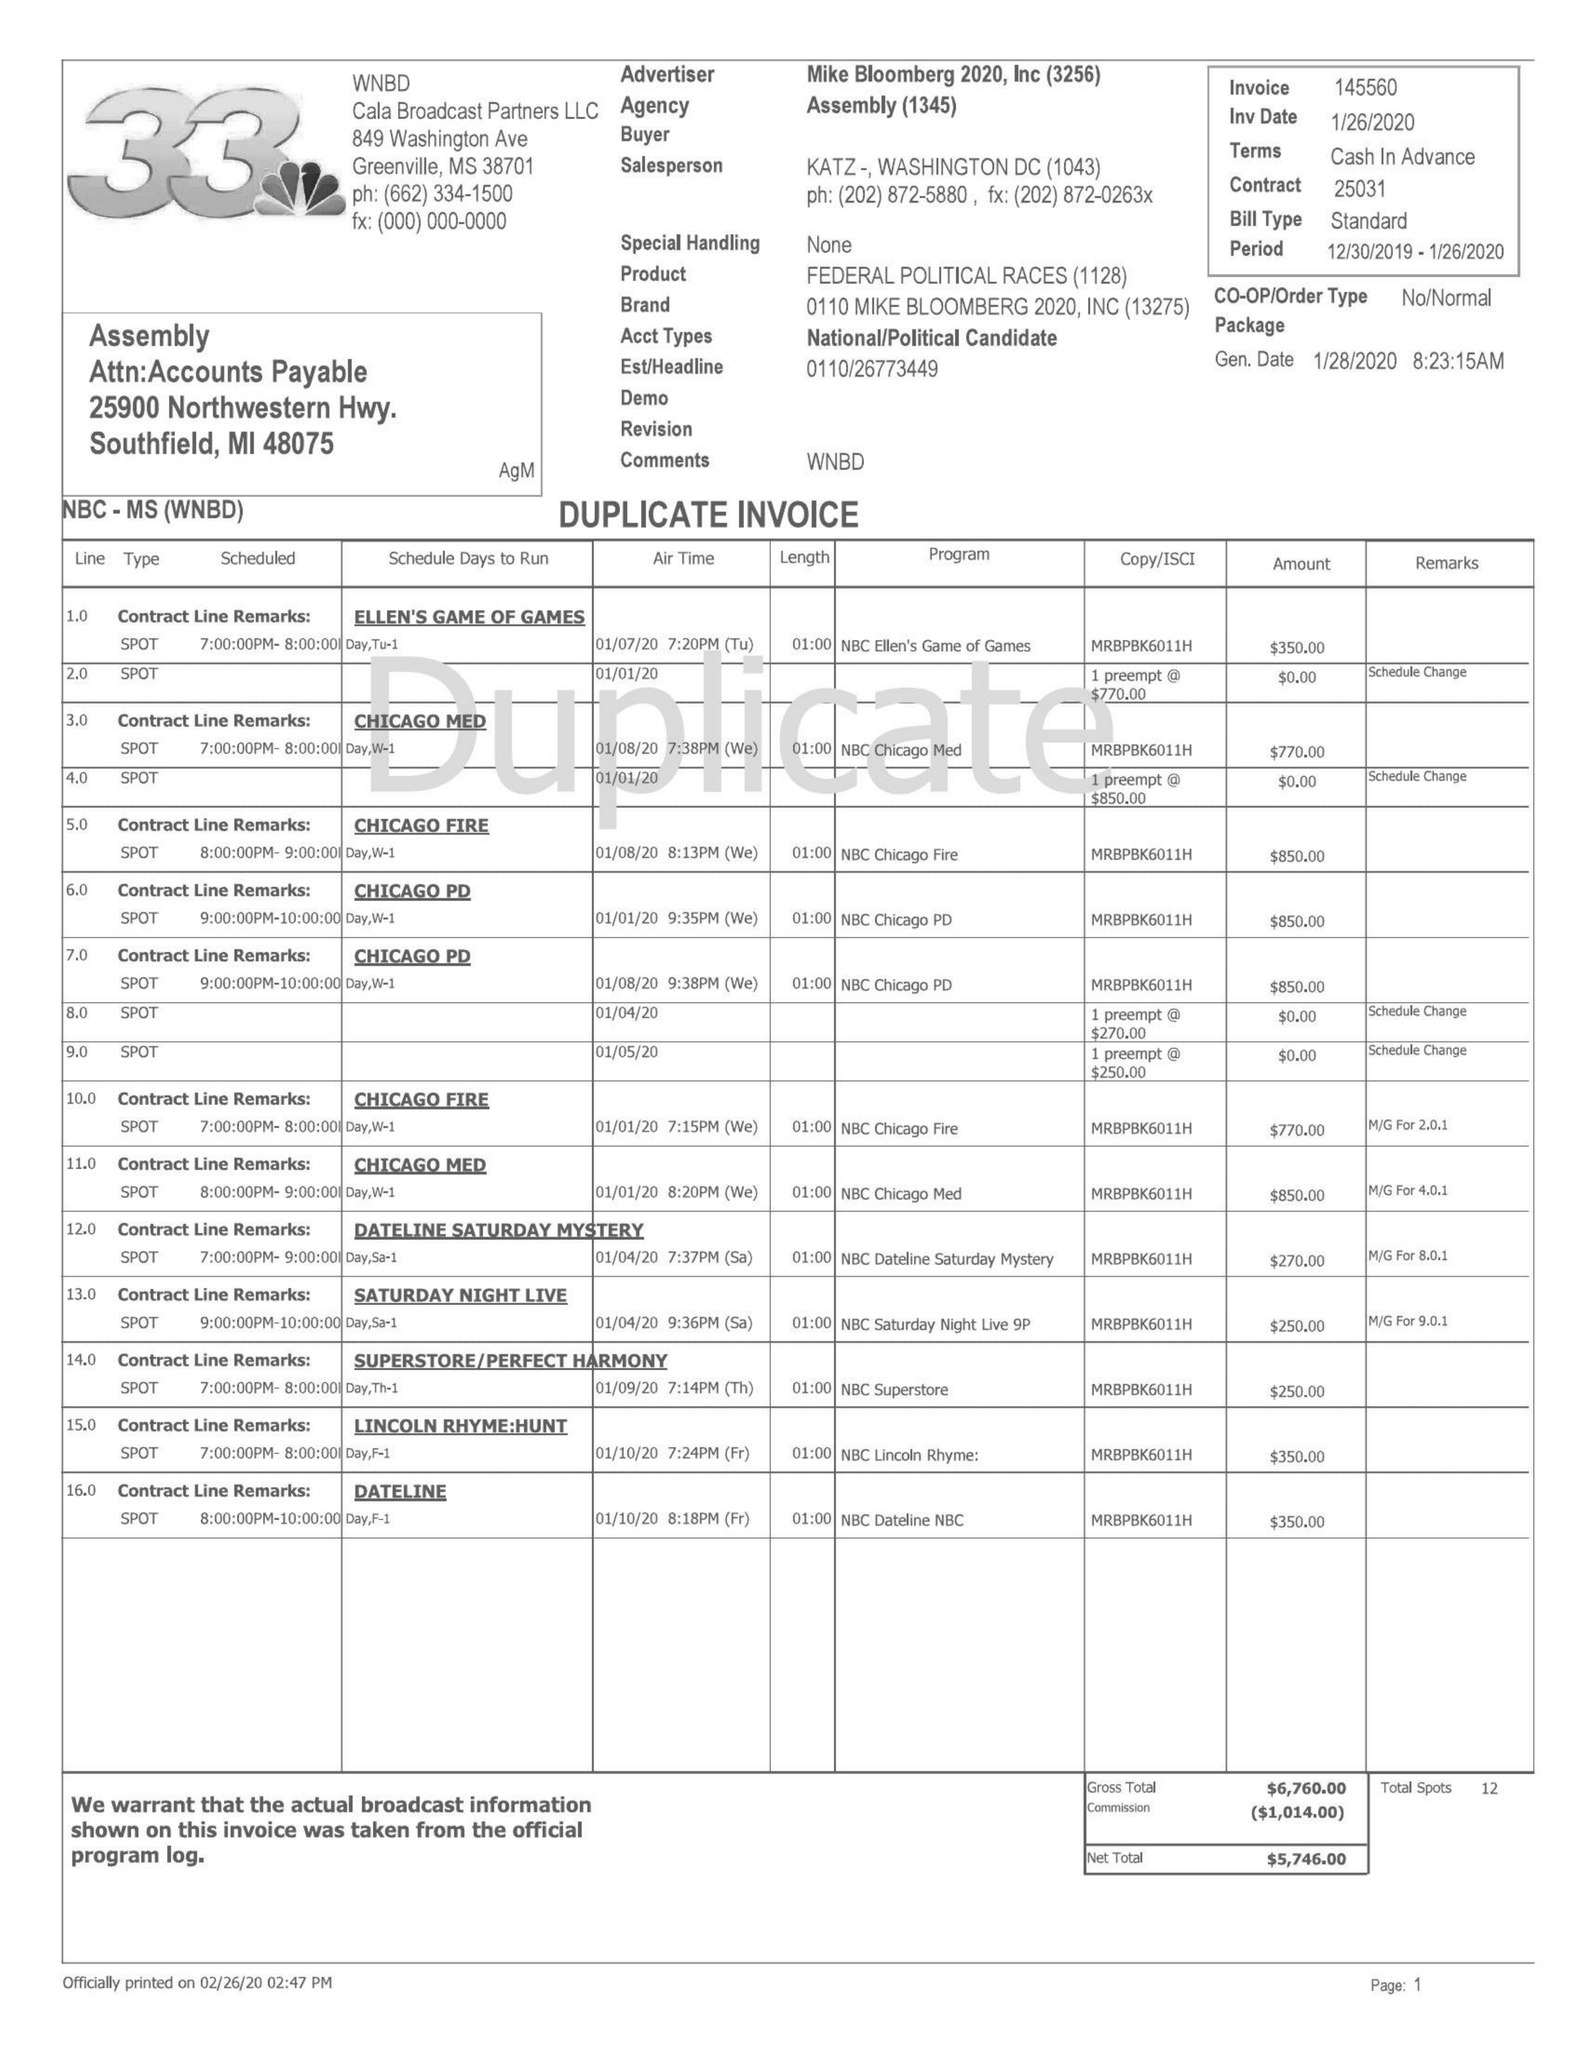What is the value for the flight_from?
Answer the question using a single word or phrase. 12/30/10 